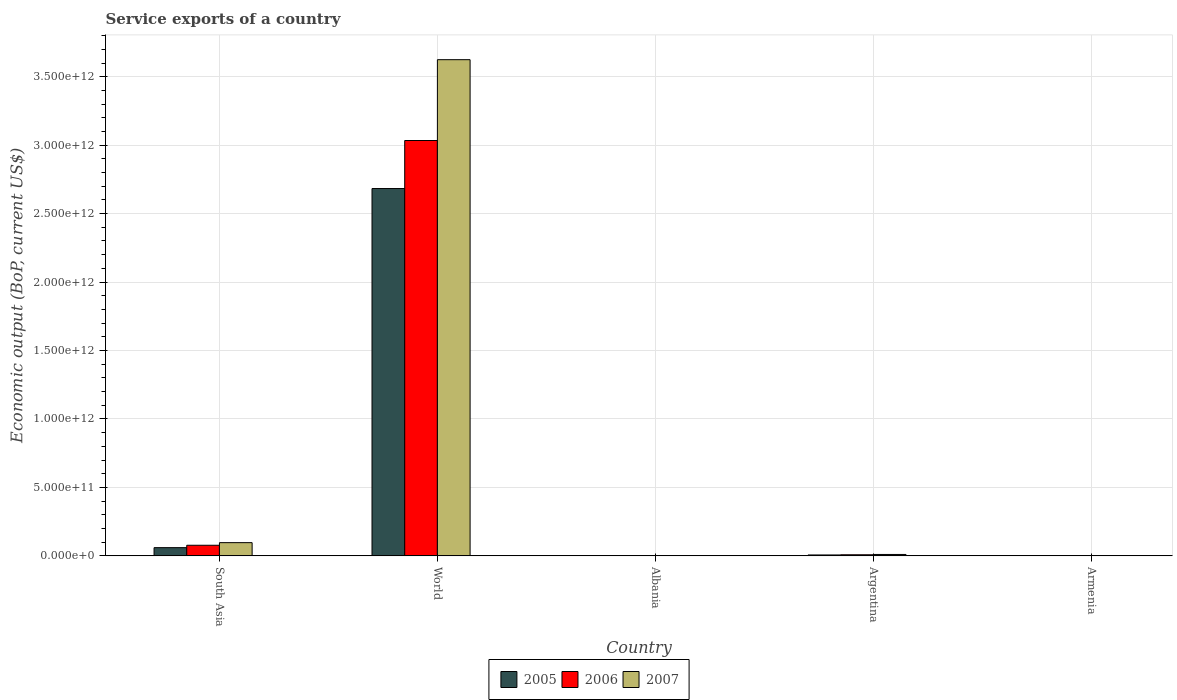Are the number of bars per tick equal to the number of legend labels?
Ensure brevity in your answer.  Yes. What is the service exports in 2006 in Argentina?
Give a very brief answer. 7.84e+09. Across all countries, what is the maximum service exports in 2005?
Provide a short and direct response. 2.68e+12. Across all countries, what is the minimum service exports in 2005?
Ensure brevity in your answer.  4.30e+08. In which country was the service exports in 2007 maximum?
Offer a very short reply. World. In which country was the service exports in 2006 minimum?
Ensure brevity in your answer.  Armenia. What is the total service exports in 2007 in the graph?
Give a very brief answer. 3.73e+12. What is the difference between the service exports in 2007 in Albania and that in South Asia?
Keep it short and to the point. -9.43e+1. What is the difference between the service exports in 2005 in Albania and the service exports in 2006 in Argentina?
Give a very brief answer. -6.57e+09. What is the average service exports in 2007 per country?
Offer a very short reply. 7.47e+11. What is the difference between the service exports of/in 2005 and service exports of/in 2007 in Armenia?
Make the answer very short. -3.34e+08. What is the ratio of the service exports in 2007 in Albania to that in South Asia?
Give a very brief answer. 0.02. Is the service exports in 2007 in Argentina less than that in World?
Offer a very short reply. Yes. What is the difference between the highest and the second highest service exports in 2007?
Make the answer very short. 3.61e+12. What is the difference between the highest and the lowest service exports in 2005?
Provide a succinct answer. 2.68e+12. Is the sum of the service exports in 2005 in Albania and World greater than the maximum service exports in 2006 across all countries?
Offer a terse response. No. What does the 3rd bar from the right in South Asia represents?
Keep it short and to the point. 2005. Is it the case that in every country, the sum of the service exports in 2007 and service exports in 2006 is greater than the service exports in 2005?
Offer a very short reply. Yes. How many bars are there?
Your answer should be very brief. 15. How many countries are there in the graph?
Ensure brevity in your answer.  5. What is the difference between two consecutive major ticks on the Y-axis?
Provide a succinct answer. 5.00e+11. Are the values on the major ticks of Y-axis written in scientific E-notation?
Your answer should be very brief. Yes. Does the graph contain grids?
Make the answer very short. Yes. How are the legend labels stacked?
Your answer should be compact. Horizontal. What is the title of the graph?
Offer a terse response. Service exports of a country. What is the label or title of the X-axis?
Make the answer very short. Country. What is the label or title of the Y-axis?
Make the answer very short. Economic output (BoP, current US$). What is the Economic output (BoP, current US$) of 2005 in South Asia?
Your response must be concise. 5.98e+1. What is the Economic output (BoP, current US$) in 2006 in South Asia?
Offer a terse response. 7.73e+1. What is the Economic output (BoP, current US$) in 2007 in South Asia?
Keep it short and to the point. 9.64e+1. What is the Economic output (BoP, current US$) in 2005 in World?
Ensure brevity in your answer.  2.68e+12. What is the Economic output (BoP, current US$) of 2006 in World?
Your response must be concise. 3.03e+12. What is the Economic output (BoP, current US$) of 2007 in World?
Ensure brevity in your answer.  3.62e+12. What is the Economic output (BoP, current US$) of 2005 in Albania?
Provide a short and direct response. 1.27e+09. What is the Economic output (BoP, current US$) in 2006 in Albania?
Your answer should be compact. 1.65e+09. What is the Economic output (BoP, current US$) in 2007 in Albania?
Your answer should be very brief. 2.10e+09. What is the Economic output (BoP, current US$) in 2005 in Argentina?
Offer a very short reply. 6.46e+09. What is the Economic output (BoP, current US$) of 2006 in Argentina?
Offer a very short reply. 7.84e+09. What is the Economic output (BoP, current US$) of 2007 in Argentina?
Give a very brief answer. 1.01e+1. What is the Economic output (BoP, current US$) of 2005 in Armenia?
Your response must be concise. 4.30e+08. What is the Economic output (BoP, current US$) of 2006 in Armenia?
Make the answer very short. 5.94e+08. What is the Economic output (BoP, current US$) of 2007 in Armenia?
Your answer should be compact. 7.64e+08. Across all countries, what is the maximum Economic output (BoP, current US$) of 2005?
Give a very brief answer. 2.68e+12. Across all countries, what is the maximum Economic output (BoP, current US$) of 2006?
Provide a succinct answer. 3.03e+12. Across all countries, what is the maximum Economic output (BoP, current US$) in 2007?
Your answer should be very brief. 3.62e+12. Across all countries, what is the minimum Economic output (BoP, current US$) in 2005?
Make the answer very short. 4.30e+08. Across all countries, what is the minimum Economic output (BoP, current US$) of 2006?
Your response must be concise. 5.94e+08. Across all countries, what is the minimum Economic output (BoP, current US$) in 2007?
Your answer should be compact. 7.64e+08. What is the total Economic output (BoP, current US$) in 2005 in the graph?
Offer a terse response. 2.75e+12. What is the total Economic output (BoP, current US$) in 2006 in the graph?
Keep it short and to the point. 3.12e+12. What is the total Economic output (BoP, current US$) in 2007 in the graph?
Offer a terse response. 3.73e+12. What is the difference between the Economic output (BoP, current US$) in 2005 in South Asia and that in World?
Provide a short and direct response. -2.62e+12. What is the difference between the Economic output (BoP, current US$) in 2006 in South Asia and that in World?
Make the answer very short. -2.96e+12. What is the difference between the Economic output (BoP, current US$) of 2007 in South Asia and that in World?
Ensure brevity in your answer.  -3.53e+12. What is the difference between the Economic output (BoP, current US$) in 2005 in South Asia and that in Albania?
Provide a succinct answer. 5.86e+1. What is the difference between the Economic output (BoP, current US$) of 2006 in South Asia and that in Albania?
Your response must be concise. 7.57e+1. What is the difference between the Economic output (BoP, current US$) in 2007 in South Asia and that in Albania?
Your response must be concise. 9.43e+1. What is the difference between the Economic output (BoP, current US$) of 2005 in South Asia and that in Argentina?
Give a very brief answer. 5.34e+1. What is the difference between the Economic output (BoP, current US$) in 2006 in South Asia and that in Argentina?
Make the answer very short. 6.95e+1. What is the difference between the Economic output (BoP, current US$) of 2007 in South Asia and that in Argentina?
Keep it short and to the point. 8.62e+1. What is the difference between the Economic output (BoP, current US$) in 2005 in South Asia and that in Armenia?
Ensure brevity in your answer.  5.94e+1. What is the difference between the Economic output (BoP, current US$) of 2006 in South Asia and that in Armenia?
Your answer should be compact. 7.67e+1. What is the difference between the Economic output (BoP, current US$) in 2007 in South Asia and that in Armenia?
Offer a very short reply. 9.56e+1. What is the difference between the Economic output (BoP, current US$) in 2005 in World and that in Albania?
Your answer should be compact. 2.68e+12. What is the difference between the Economic output (BoP, current US$) in 2006 in World and that in Albania?
Keep it short and to the point. 3.03e+12. What is the difference between the Economic output (BoP, current US$) in 2007 in World and that in Albania?
Make the answer very short. 3.62e+12. What is the difference between the Economic output (BoP, current US$) in 2005 in World and that in Argentina?
Offer a very short reply. 2.68e+12. What is the difference between the Economic output (BoP, current US$) of 2006 in World and that in Argentina?
Make the answer very short. 3.03e+12. What is the difference between the Economic output (BoP, current US$) in 2007 in World and that in Argentina?
Ensure brevity in your answer.  3.61e+12. What is the difference between the Economic output (BoP, current US$) of 2005 in World and that in Armenia?
Your response must be concise. 2.68e+12. What is the difference between the Economic output (BoP, current US$) in 2006 in World and that in Armenia?
Your response must be concise. 3.03e+12. What is the difference between the Economic output (BoP, current US$) in 2007 in World and that in Armenia?
Ensure brevity in your answer.  3.62e+12. What is the difference between the Economic output (BoP, current US$) in 2005 in Albania and that in Argentina?
Your response must be concise. -5.19e+09. What is the difference between the Economic output (BoP, current US$) of 2006 in Albania and that in Argentina?
Make the answer very short. -6.19e+09. What is the difference between the Economic output (BoP, current US$) in 2007 in Albania and that in Argentina?
Your answer should be compact. -8.03e+09. What is the difference between the Economic output (BoP, current US$) in 2005 in Albania and that in Armenia?
Provide a succinct answer. 8.37e+08. What is the difference between the Economic output (BoP, current US$) in 2006 in Albania and that in Armenia?
Give a very brief answer. 1.05e+09. What is the difference between the Economic output (BoP, current US$) of 2007 in Albania and that in Armenia?
Ensure brevity in your answer.  1.34e+09. What is the difference between the Economic output (BoP, current US$) of 2005 in Argentina and that in Armenia?
Give a very brief answer. 6.03e+09. What is the difference between the Economic output (BoP, current US$) of 2006 in Argentina and that in Armenia?
Provide a short and direct response. 7.24e+09. What is the difference between the Economic output (BoP, current US$) in 2007 in Argentina and that in Armenia?
Keep it short and to the point. 9.37e+09. What is the difference between the Economic output (BoP, current US$) in 2005 in South Asia and the Economic output (BoP, current US$) in 2006 in World?
Offer a terse response. -2.97e+12. What is the difference between the Economic output (BoP, current US$) in 2005 in South Asia and the Economic output (BoP, current US$) in 2007 in World?
Offer a very short reply. -3.56e+12. What is the difference between the Economic output (BoP, current US$) in 2006 in South Asia and the Economic output (BoP, current US$) in 2007 in World?
Your answer should be compact. -3.55e+12. What is the difference between the Economic output (BoP, current US$) of 2005 in South Asia and the Economic output (BoP, current US$) of 2006 in Albania?
Your response must be concise. 5.82e+1. What is the difference between the Economic output (BoP, current US$) in 2005 in South Asia and the Economic output (BoP, current US$) in 2007 in Albania?
Keep it short and to the point. 5.77e+1. What is the difference between the Economic output (BoP, current US$) in 2006 in South Asia and the Economic output (BoP, current US$) in 2007 in Albania?
Provide a succinct answer. 7.52e+1. What is the difference between the Economic output (BoP, current US$) in 2005 in South Asia and the Economic output (BoP, current US$) in 2006 in Argentina?
Provide a short and direct response. 5.20e+1. What is the difference between the Economic output (BoP, current US$) in 2005 in South Asia and the Economic output (BoP, current US$) in 2007 in Argentina?
Provide a short and direct response. 4.97e+1. What is the difference between the Economic output (BoP, current US$) of 2006 in South Asia and the Economic output (BoP, current US$) of 2007 in Argentina?
Offer a terse response. 6.72e+1. What is the difference between the Economic output (BoP, current US$) in 2005 in South Asia and the Economic output (BoP, current US$) in 2006 in Armenia?
Your response must be concise. 5.92e+1. What is the difference between the Economic output (BoP, current US$) in 2005 in South Asia and the Economic output (BoP, current US$) in 2007 in Armenia?
Make the answer very short. 5.91e+1. What is the difference between the Economic output (BoP, current US$) in 2006 in South Asia and the Economic output (BoP, current US$) in 2007 in Armenia?
Ensure brevity in your answer.  7.65e+1. What is the difference between the Economic output (BoP, current US$) in 2005 in World and the Economic output (BoP, current US$) in 2006 in Albania?
Offer a terse response. 2.68e+12. What is the difference between the Economic output (BoP, current US$) of 2005 in World and the Economic output (BoP, current US$) of 2007 in Albania?
Ensure brevity in your answer.  2.68e+12. What is the difference between the Economic output (BoP, current US$) in 2006 in World and the Economic output (BoP, current US$) in 2007 in Albania?
Offer a very short reply. 3.03e+12. What is the difference between the Economic output (BoP, current US$) in 2005 in World and the Economic output (BoP, current US$) in 2006 in Argentina?
Give a very brief answer. 2.68e+12. What is the difference between the Economic output (BoP, current US$) of 2005 in World and the Economic output (BoP, current US$) of 2007 in Argentina?
Keep it short and to the point. 2.67e+12. What is the difference between the Economic output (BoP, current US$) in 2006 in World and the Economic output (BoP, current US$) in 2007 in Argentina?
Offer a very short reply. 3.02e+12. What is the difference between the Economic output (BoP, current US$) in 2005 in World and the Economic output (BoP, current US$) in 2006 in Armenia?
Your answer should be compact. 2.68e+12. What is the difference between the Economic output (BoP, current US$) of 2005 in World and the Economic output (BoP, current US$) of 2007 in Armenia?
Your response must be concise. 2.68e+12. What is the difference between the Economic output (BoP, current US$) of 2006 in World and the Economic output (BoP, current US$) of 2007 in Armenia?
Give a very brief answer. 3.03e+12. What is the difference between the Economic output (BoP, current US$) in 2005 in Albania and the Economic output (BoP, current US$) in 2006 in Argentina?
Keep it short and to the point. -6.57e+09. What is the difference between the Economic output (BoP, current US$) of 2005 in Albania and the Economic output (BoP, current US$) of 2007 in Argentina?
Your response must be concise. -8.87e+09. What is the difference between the Economic output (BoP, current US$) of 2006 in Albania and the Economic output (BoP, current US$) of 2007 in Argentina?
Your response must be concise. -8.49e+09. What is the difference between the Economic output (BoP, current US$) in 2005 in Albania and the Economic output (BoP, current US$) in 2006 in Armenia?
Offer a very short reply. 6.73e+08. What is the difference between the Economic output (BoP, current US$) of 2005 in Albania and the Economic output (BoP, current US$) of 2007 in Armenia?
Ensure brevity in your answer.  5.02e+08. What is the difference between the Economic output (BoP, current US$) of 2006 in Albania and the Economic output (BoP, current US$) of 2007 in Armenia?
Provide a succinct answer. 8.82e+08. What is the difference between the Economic output (BoP, current US$) in 2005 in Argentina and the Economic output (BoP, current US$) in 2006 in Armenia?
Provide a succinct answer. 5.86e+09. What is the difference between the Economic output (BoP, current US$) of 2005 in Argentina and the Economic output (BoP, current US$) of 2007 in Armenia?
Offer a terse response. 5.69e+09. What is the difference between the Economic output (BoP, current US$) in 2006 in Argentina and the Economic output (BoP, current US$) in 2007 in Armenia?
Offer a very short reply. 7.07e+09. What is the average Economic output (BoP, current US$) in 2005 per country?
Keep it short and to the point. 5.50e+11. What is the average Economic output (BoP, current US$) in 2006 per country?
Give a very brief answer. 6.24e+11. What is the average Economic output (BoP, current US$) in 2007 per country?
Ensure brevity in your answer.  7.47e+11. What is the difference between the Economic output (BoP, current US$) of 2005 and Economic output (BoP, current US$) of 2006 in South Asia?
Provide a succinct answer. -1.75e+1. What is the difference between the Economic output (BoP, current US$) in 2005 and Economic output (BoP, current US$) in 2007 in South Asia?
Give a very brief answer. -3.65e+1. What is the difference between the Economic output (BoP, current US$) of 2006 and Economic output (BoP, current US$) of 2007 in South Asia?
Your answer should be compact. -1.91e+1. What is the difference between the Economic output (BoP, current US$) of 2005 and Economic output (BoP, current US$) of 2006 in World?
Give a very brief answer. -3.51e+11. What is the difference between the Economic output (BoP, current US$) in 2005 and Economic output (BoP, current US$) in 2007 in World?
Provide a succinct answer. -9.41e+11. What is the difference between the Economic output (BoP, current US$) in 2006 and Economic output (BoP, current US$) in 2007 in World?
Make the answer very short. -5.90e+11. What is the difference between the Economic output (BoP, current US$) in 2005 and Economic output (BoP, current US$) in 2006 in Albania?
Provide a succinct answer. -3.79e+08. What is the difference between the Economic output (BoP, current US$) in 2005 and Economic output (BoP, current US$) in 2007 in Albania?
Your answer should be compact. -8.38e+08. What is the difference between the Economic output (BoP, current US$) in 2006 and Economic output (BoP, current US$) in 2007 in Albania?
Give a very brief answer. -4.59e+08. What is the difference between the Economic output (BoP, current US$) in 2005 and Economic output (BoP, current US$) in 2006 in Argentina?
Offer a very short reply. -1.38e+09. What is the difference between the Economic output (BoP, current US$) in 2005 and Economic output (BoP, current US$) in 2007 in Argentina?
Offer a terse response. -3.68e+09. What is the difference between the Economic output (BoP, current US$) of 2006 and Economic output (BoP, current US$) of 2007 in Argentina?
Your answer should be very brief. -2.30e+09. What is the difference between the Economic output (BoP, current US$) of 2005 and Economic output (BoP, current US$) of 2006 in Armenia?
Your answer should be very brief. -1.64e+08. What is the difference between the Economic output (BoP, current US$) of 2005 and Economic output (BoP, current US$) of 2007 in Armenia?
Offer a terse response. -3.34e+08. What is the difference between the Economic output (BoP, current US$) in 2006 and Economic output (BoP, current US$) in 2007 in Armenia?
Your answer should be very brief. -1.70e+08. What is the ratio of the Economic output (BoP, current US$) in 2005 in South Asia to that in World?
Your answer should be compact. 0.02. What is the ratio of the Economic output (BoP, current US$) in 2006 in South Asia to that in World?
Give a very brief answer. 0.03. What is the ratio of the Economic output (BoP, current US$) in 2007 in South Asia to that in World?
Keep it short and to the point. 0.03. What is the ratio of the Economic output (BoP, current US$) in 2005 in South Asia to that in Albania?
Make the answer very short. 47.24. What is the ratio of the Economic output (BoP, current US$) in 2006 in South Asia to that in Albania?
Provide a succinct answer. 46.97. What is the ratio of the Economic output (BoP, current US$) in 2007 in South Asia to that in Albania?
Give a very brief answer. 45.79. What is the ratio of the Economic output (BoP, current US$) in 2005 in South Asia to that in Argentina?
Provide a short and direct response. 9.26. What is the ratio of the Economic output (BoP, current US$) of 2006 in South Asia to that in Argentina?
Give a very brief answer. 9.86. What is the ratio of the Economic output (BoP, current US$) of 2007 in South Asia to that in Argentina?
Offer a terse response. 9.51. What is the ratio of the Economic output (BoP, current US$) in 2005 in South Asia to that in Armenia?
Give a very brief answer. 139.09. What is the ratio of the Economic output (BoP, current US$) of 2006 in South Asia to that in Armenia?
Your response must be concise. 130.2. What is the ratio of the Economic output (BoP, current US$) of 2007 in South Asia to that in Armenia?
Offer a very short reply. 126.1. What is the ratio of the Economic output (BoP, current US$) in 2005 in World to that in Albania?
Offer a very short reply. 2118.23. What is the ratio of the Economic output (BoP, current US$) of 2006 in World to that in Albania?
Ensure brevity in your answer.  1843.27. What is the ratio of the Economic output (BoP, current US$) in 2007 in World to that in Albania?
Keep it short and to the point. 1722.11. What is the ratio of the Economic output (BoP, current US$) of 2005 in World to that in Argentina?
Keep it short and to the point. 415.46. What is the ratio of the Economic output (BoP, current US$) of 2006 in World to that in Argentina?
Your answer should be compact. 387.11. What is the ratio of the Economic output (BoP, current US$) in 2007 in World to that in Argentina?
Make the answer very short. 357.53. What is the ratio of the Economic output (BoP, current US$) in 2005 in World to that in Armenia?
Your answer should be very brief. 6237.51. What is the ratio of the Economic output (BoP, current US$) of 2006 in World to that in Armenia?
Your answer should be compact. 5109.91. What is the ratio of the Economic output (BoP, current US$) of 2007 in World to that in Armenia?
Your response must be concise. 4742.44. What is the ratio of the Economic output (BoP, current US$) in 2005 in Albania to that in Argentina?
Your answer should be compact. 0.2. What is the ratio of the Economic output (BoP, current US$) in 2006 in Albania to that in Argentina?
Make the answer very short. 0.21. What is the ratio of the Economic output (BoP, current US$) in 2007 in Albania to that in Argentina?
Provide a short and direct response. 0.21. What is the ratio of the Economic output (BoP, current US$) in 2005 in Albania to that in Armenia?
Keep it short and to the point. 2.94. What is the ratio of the Economic output (BoP, current US$) of 2006 in Albania to that in Armenia?
Offer a very short reply. 2.77. What is the ratio of the Economic output (BoP, current US$) in 2007 in Albania to that in Armenia?
Provide a short and direct response. 2.75. What is the ratio of the Economic output (BoP, current US$) of 2005 in Argentina to that in Armenia?
Give a very brief answer. 15.01. What is the ratio of the Economic output (BoP, current US$) in 2006 in Argentina to that in Armenia?
Give a very brief answer. 13.2. What is the ratio of the Economic output (BoP, current US$) of 2007 in Argentina to that in Armenia?
Your answer should be compact. 13.26. What is the difference between the highest and the second highest Economic output (BoP, current US$) in 2005?
Your response must be concise. 2.62e+12. What is the difference between the highest and the second highest Economic output (BoP, current US$) in 2006?
Your answer should be very brief. 2.96e+12. What is the difference between the highest and the second highest Economic output (BoP, current US$) of 2007?
Provide a succinct answer. 3.53e+12. What is the difference between the highest and the lowest Economic output (BoP, current US$) in 2005?
Make the answer very short. 2.68e+12. What is the difference between the highest and the lowest Economic output (BoP, current US$) in 2006?
Give a very brief answer. 3.03e+12. What is the difference between the highest and the lowest Economic output (BoP, current US$) in 2007?
Offer a very short reply. 3.62e+12. 